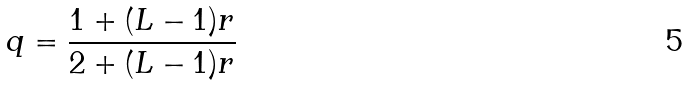Convert formula to latex. <formula><loc_0><loc_0><loc_500><loc_500>q = \frac { 1 + ( L - 1 ) r } { 2 + ( L - 1 ) r }</formula> 